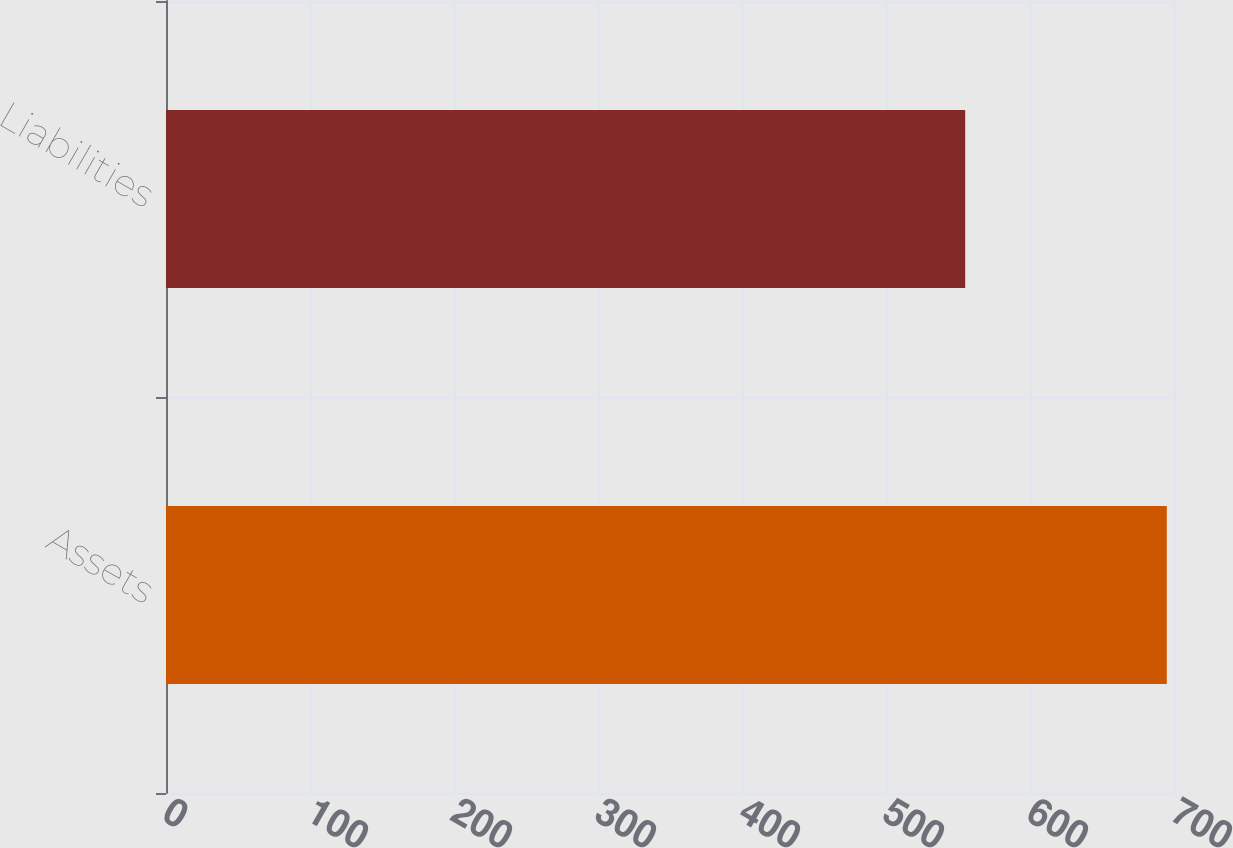Convert chart to OTSL. <chart><loc_0><loc_0><loc_500><loc_500><bar_chart><fcel>Assets<fcel>Liabilities<nl><fcel>695<fcel>555<nl></chart> 